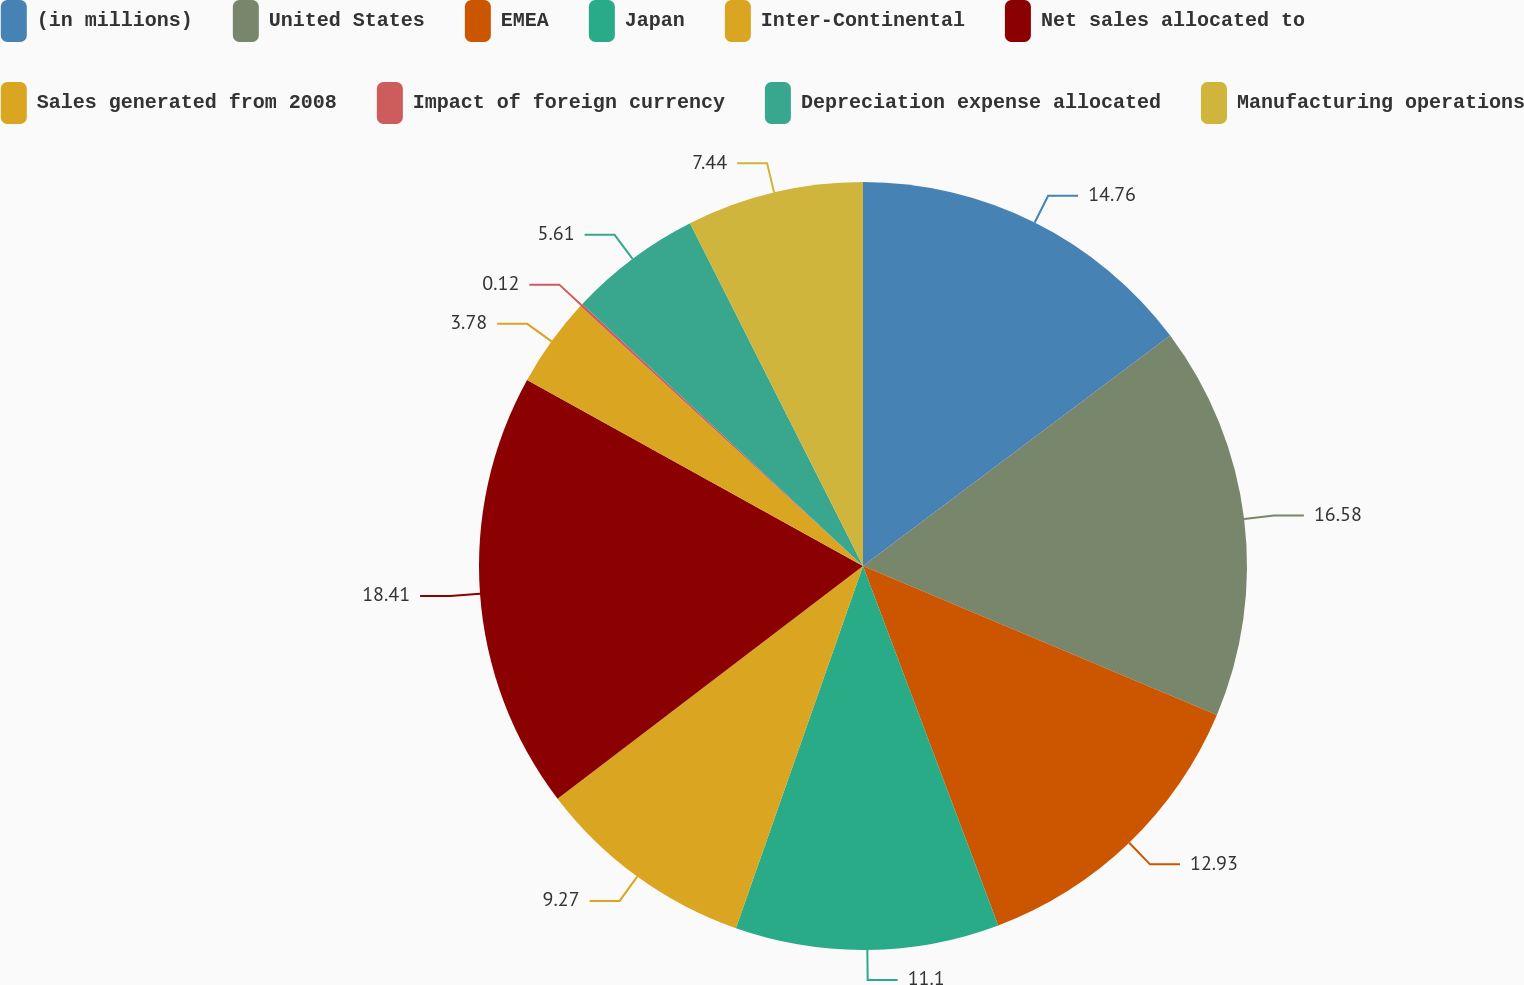Convert chart to OTSL. <chart><loc_0><loc_0><loc_500><loc_500><pie_chart><fcel>(in millions)<fcel>United States<fcel>EMEA<fcel>Japan<fcel>Inter-Continental<fcel>Net sales allocated to<fcel>Sales generated from 2008<fcel>Impact of foreign currency<fcel>Depreciation expense allocated<fcel>Manufacturing operations<nl><fcel>14.76%<fcel>16.59%<fcel>12.93%<fcel>11.1%<fcel>9.27%<fcel>18.42%<fcel>3.78%<fcel>0.12%<fcel>5.61%<fcel>7.44%<nl></chart> 